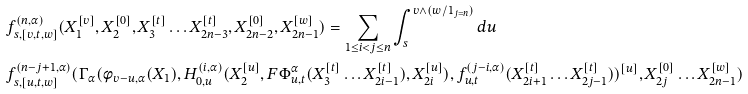<formula> <loc_0><loc_0><loc_500><loc_500>& f _ { s , [ v , t , w ] } ^ { ( n , \alpha ) } ( X _ { 1 } ^ { [ v ] } , X _ { 2 } ^ { [ 0 ] } , X _ { 3 } ^ { [ t ] } \dots X _ { 2 n - 3 } ^ { [ t ] } , X _ { 2 n - 2 } ^ { [ 0 ] } , X _ { 2 n - 1 } ^ { [ w ] } ) = \sum _ { 1 \leq i < j \leq n } \int _ { s } ^ { v \wedge ( w / 1 _ { j = n } ) } d u \ \\ & f _ { s , [ u , t , w ] } ^ { ( n - j + 1 , \alpha ) } ( \Gamma _ { \alpha } ( \phi _ { v - u , \alpha } ( X _ { 1 } ) , H _ { 0 , u } ^ { ( i , \alpha ) } ( X _ { 2 } ^ { [ u ] } , F \Phi _ { u , t } ^ { \alpha } ( X _ { 3 } ^ { [ t ] } \dots X _ { 2 i - 1 } ^ { [ t ] } ) , X _ { 2 i } ^ { [ u ] } ) , f _ { u , t } ^ { ( j - i , \alpha ) } ( X _ { 2 i + 1 } ^ { [ t ] } \dots X _ { 2 j - 1 } ^ { [ t ] } ) ) ^ { [ u ] } , X _ { 2 j } ^ { [ 0 ] } \dots X _ { 2 n - 1 } ^ { [ w ] } )</formula> 